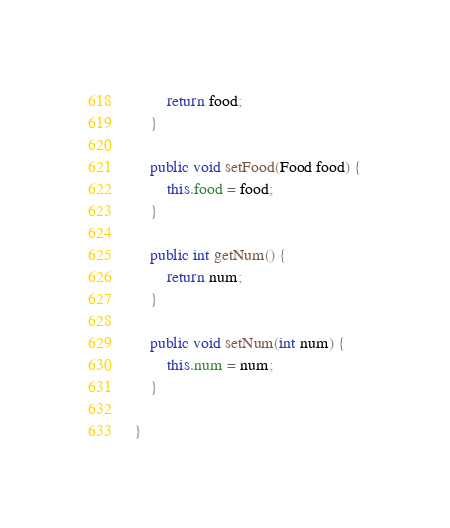<code> <loc_0><loc_0><loc_500><loc_500><_Java_>		return food;
	}
	
	public void setFood(Food food) {
		this.food = food;
	}
	
	public int getNum() {
		return num;
	}
	
	public void setNum(int num) {
		this.num = num;
	}
	
}
</code> 